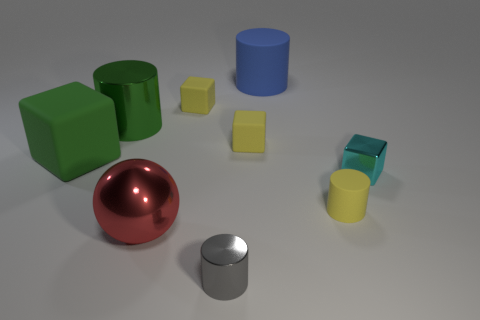Subtract 1 cylinders. How many cylinders are left? 3 Add 1 tiny brown metallic cylinders. How many objects exist? 10 Subtract all cylinders. How many objects are left? 5 Add 4 rubber cylinders. How many rubber cylinders exist? 6 Subtract 0 yellow spheres. How many objects are left? 9 Subtract all green cylinders. Subtract all small yellow matte objects. How many objects are left? 5 Add 9 blue cylinders. How many blue cylinders are left? 10 